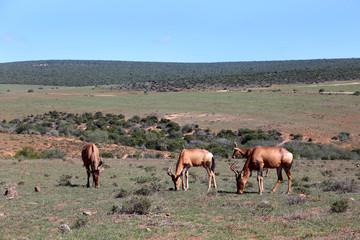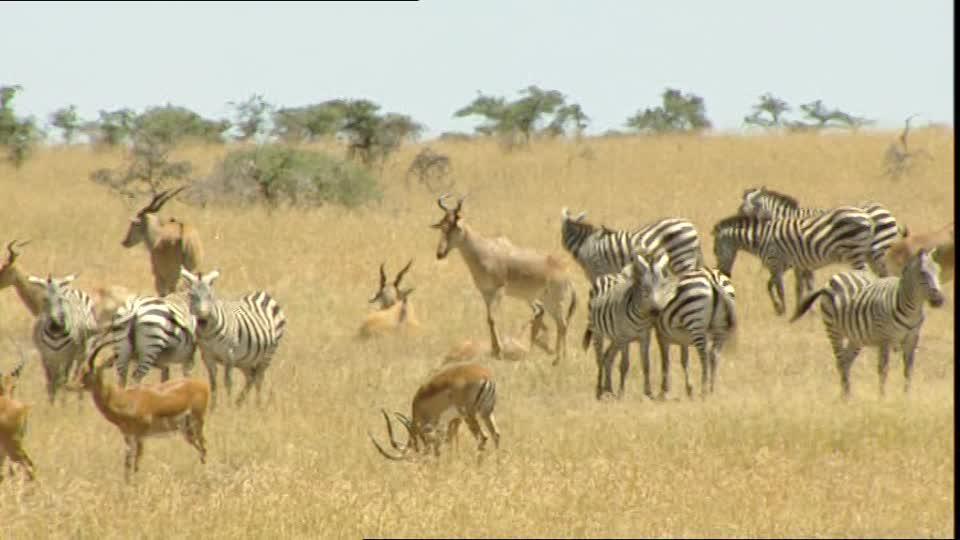The first image is the image on the left, the second image is the image on the right. Examine the images to the left and right. Is the description "There are a number of zebras among the other types of animals present." accurate? Answer yes or no. Yes. The first image is the image on the left, the second image is the image on the right. Analyze the images presented: Is the assertion "Zebras and antelopes are mingling together." valid? Answer yes or no. Yes. 